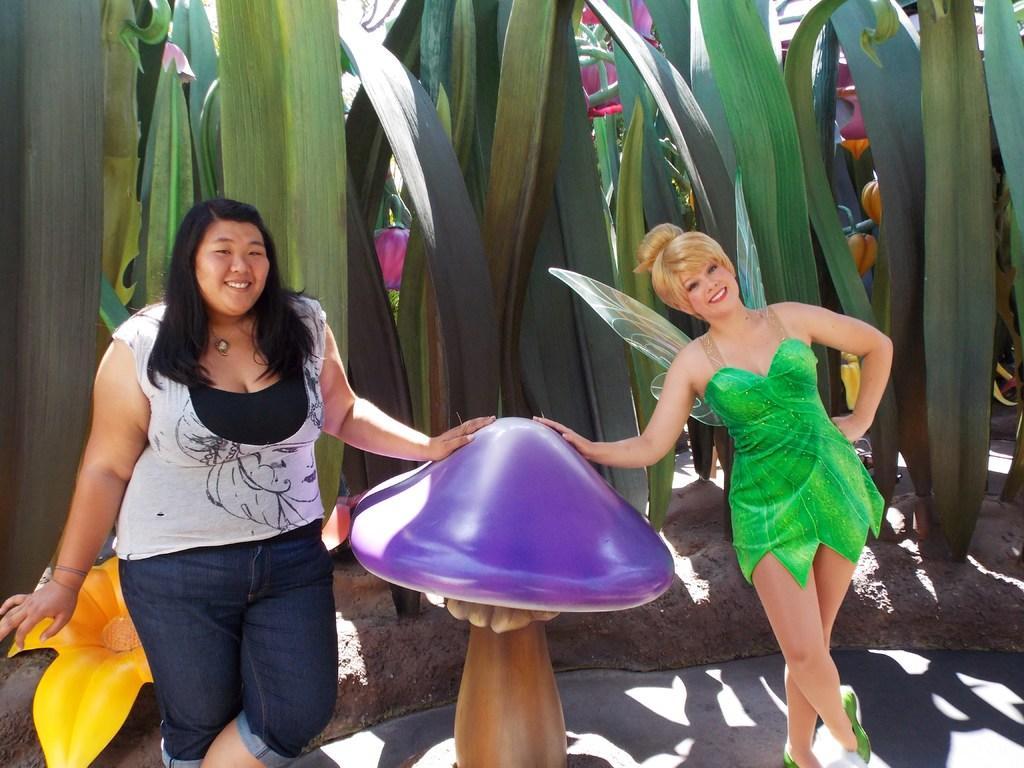Could you give a brief overview of what you see in this image? In this picture there is a woman who is wearing white t-shirt, jeans and locket. She is standing near to the purple color mushroom. Beside her I can see another woman who is wearing green dress. Behind them I can see the leaves. 